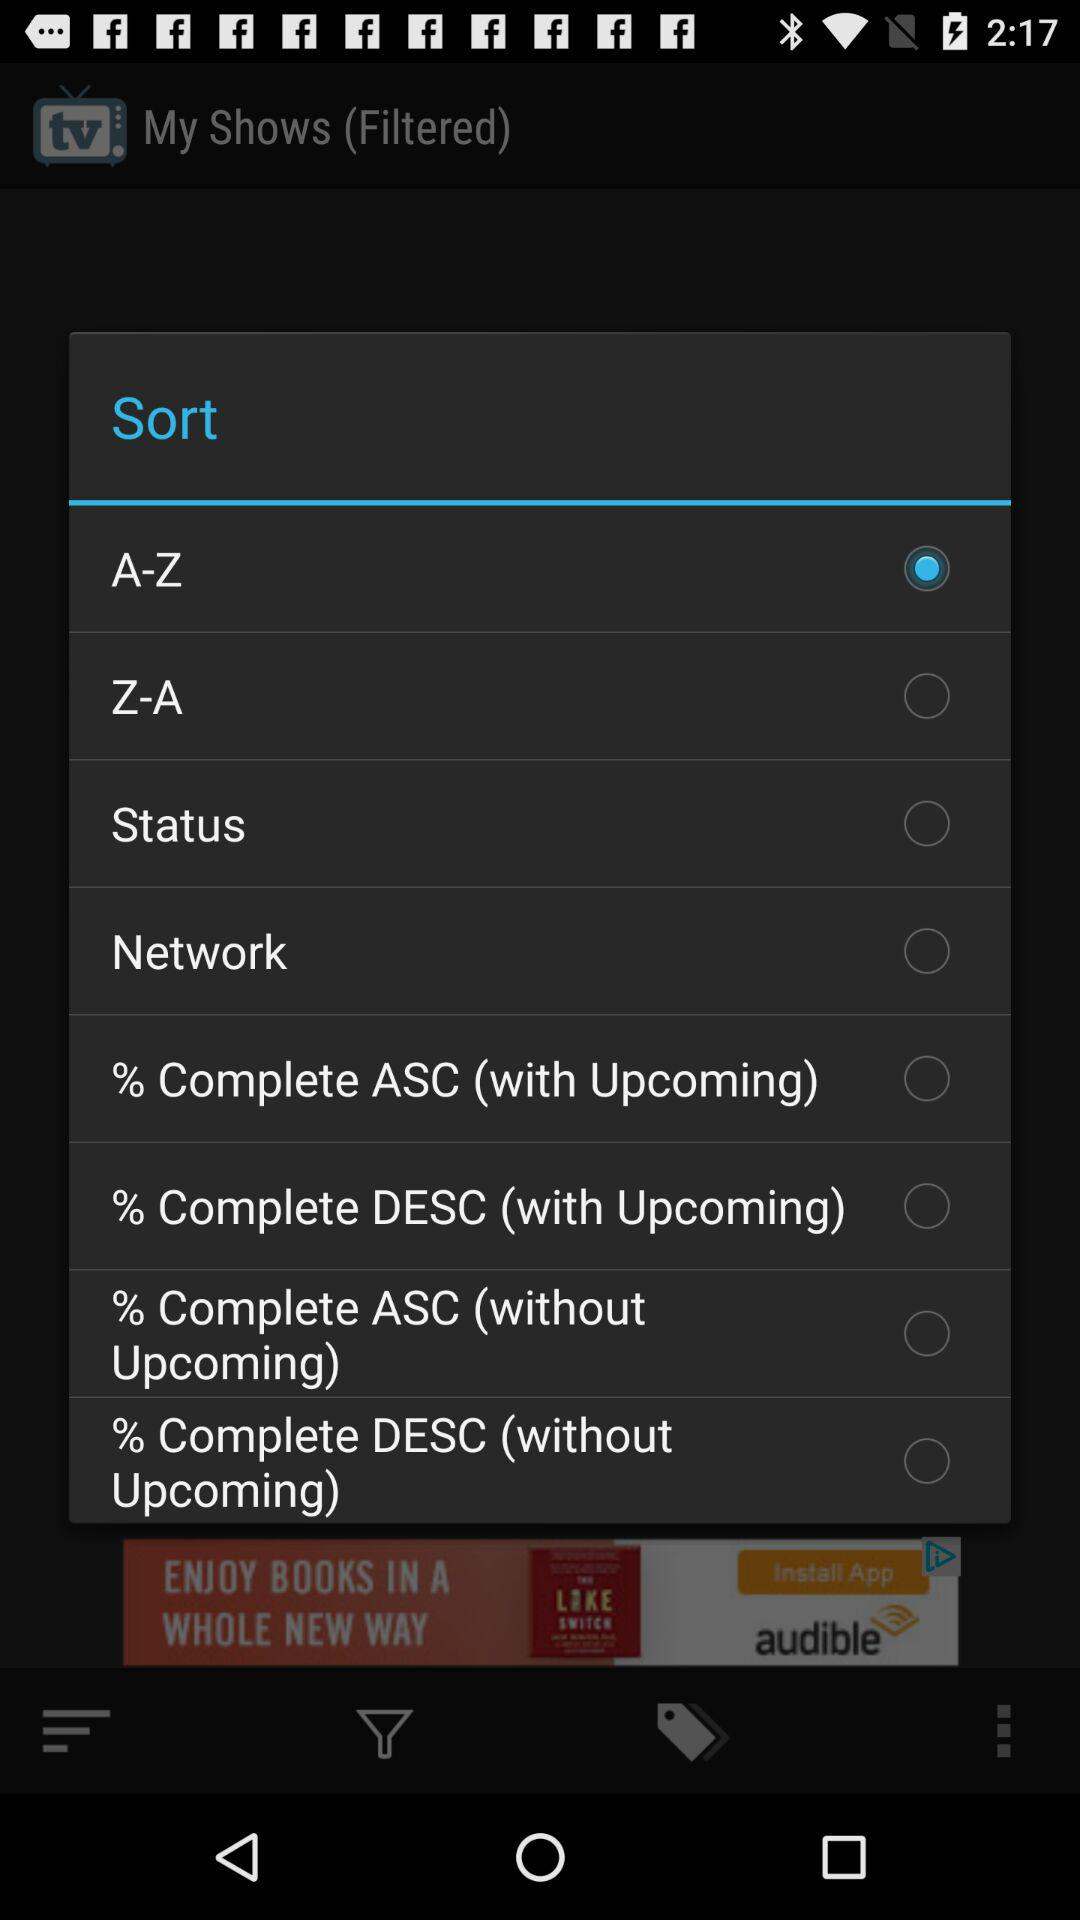Who is this application powered by?
When the provided information is insufficient, respond with <no answer>. <no answer> 